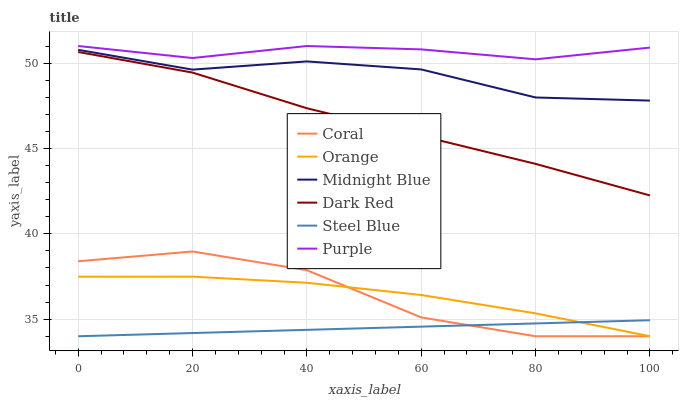Does Steel Blue have the minimum area under the curve?
Answer yes or no. Yes. Does Purple have the maximum area under the curve?
Answer yes or no. Yes. Does Dark Red have the minimum area under the curve?
Answer yes or no. No. Does Dark Red have the maximum area under the curve?
Answer yes or no. No. Is Steel Blue the smoothest?
Answer yes or no. Yes. Is Coral the roughest?
Answer yes or no. Yes. Is Purple the smoothest?
Answer yes or no. No. Is Purple the roughest?
Answer yes or no. No. Does Coral have the lowest value?
Answer yes or no. Yes. Does Dark Red have the lowest value?
Answer yes or no. No. Does Purple have the highest value?
Answer yes or no. Yes. Does Dark Red have the highest value?
Answer yes or no. No. Is Dark Red less than Purple?
Answer yes or no. Yes. Is Dark Red greater than Coral?
Answer yes or no. Yes. Does Steel Blue intersect Coral?
Answer yes or no. Yes. Is Steel Blue less than Coral?
Answer yes or no. No. Is Steel Blue greater than Coral?
Answer yes or no. No. Does Dark Red intersect Purple?
Answer yes or no. No. 